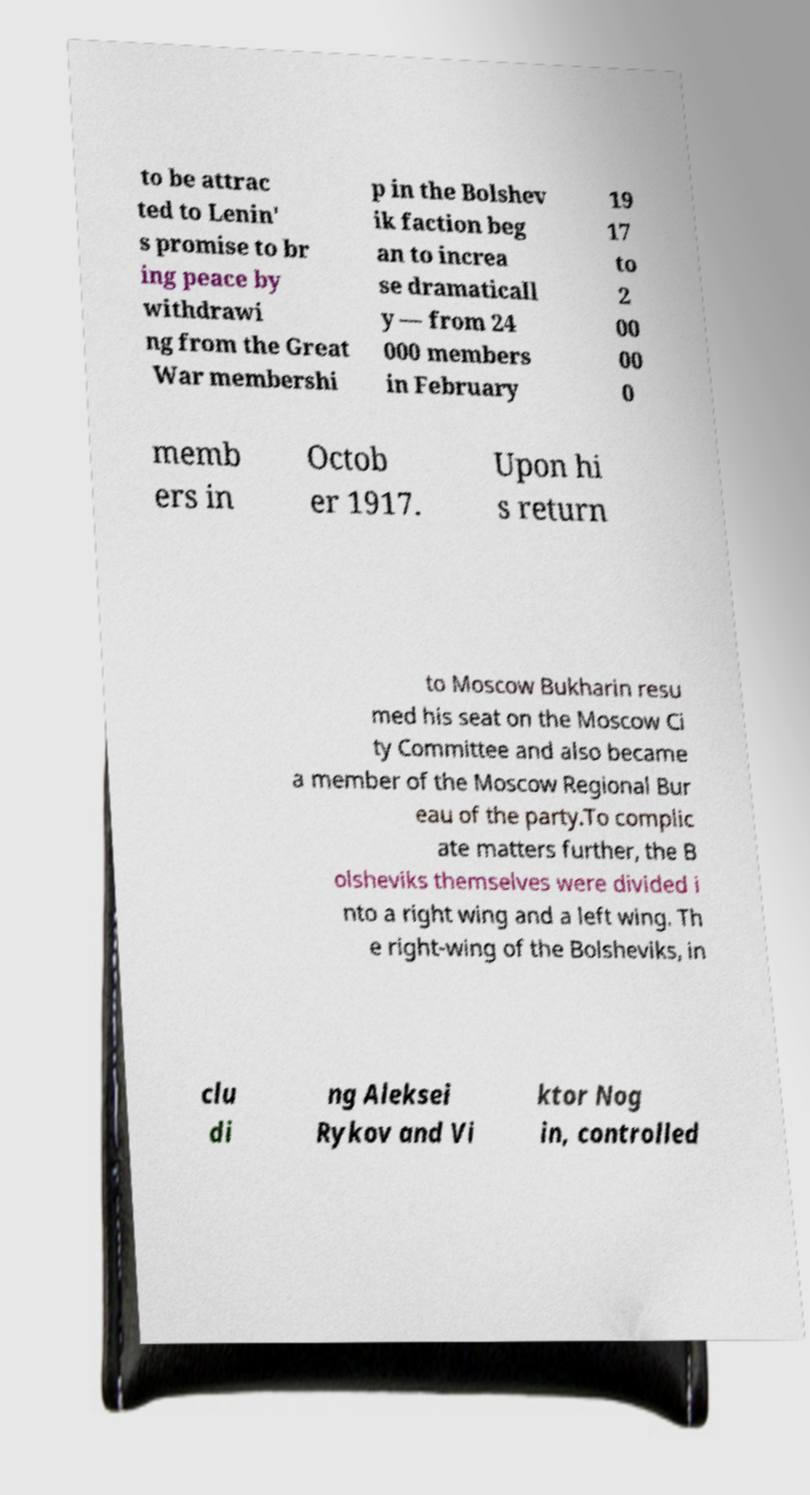For documentation purposes, I need the text within this image transcribed. Could you provide that? to be attrac ted to Lenin' s promise to br ing peace by withdrawi ng from the Great War membershi p in the Bolshev ik faction beg an to increa se dramaticall y — from 24 000 members in February 19 17 to 2 00 00 0 memb ers in Octob er 1917. Upon hi s return to Moscow Bukharin resu med his seat on the Moscow Ci ty Committee and also became a member of the Moscow Regional Bur eau of the party.To complic ate matters further, the B olsheviks themselves were divided i nto a right wing and a left wing. Th e right-wing of the Bolsheviks, in clu di ng Aleksei Rykov and Vi ktor Nog in, controlled 